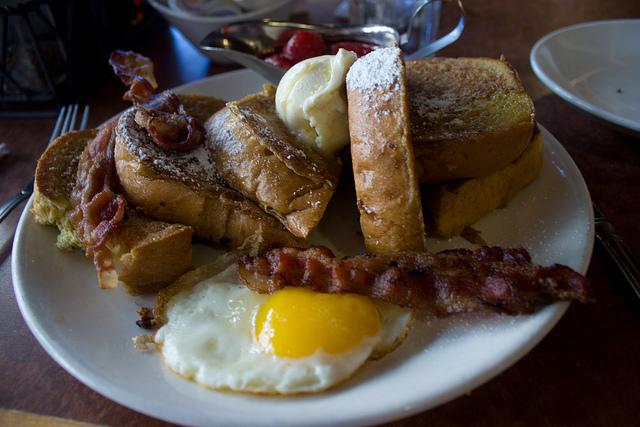What utensil will be used to eat this food?
Short answer required. Fork. Is there a sandwich on the plate?
Be succinct. No. What time of day is this meal typically served?
Write a very short answer. Morning. Are there any alcoholic beverages present?
Concise answer only. No. How many pieces of ham are on the plate?
Answer briefly. 0. How many fried eggs can be seen?
Concise answer only. 1. Are there tomato slices?
Write a very short answer. No. Is this breakfast?
Write a very short answer. Yes. Do you see a hard boiled egg?
Be succinct. No. Are these edibles artistically arranged?
Answer briefly. No. Are the objects with the red coloring edible for humans?
Give a very brief answer. Yes. What is on the egg?
Concise answer only. Bacon. Is there a napkin on the table?
Concise answer only. No. 